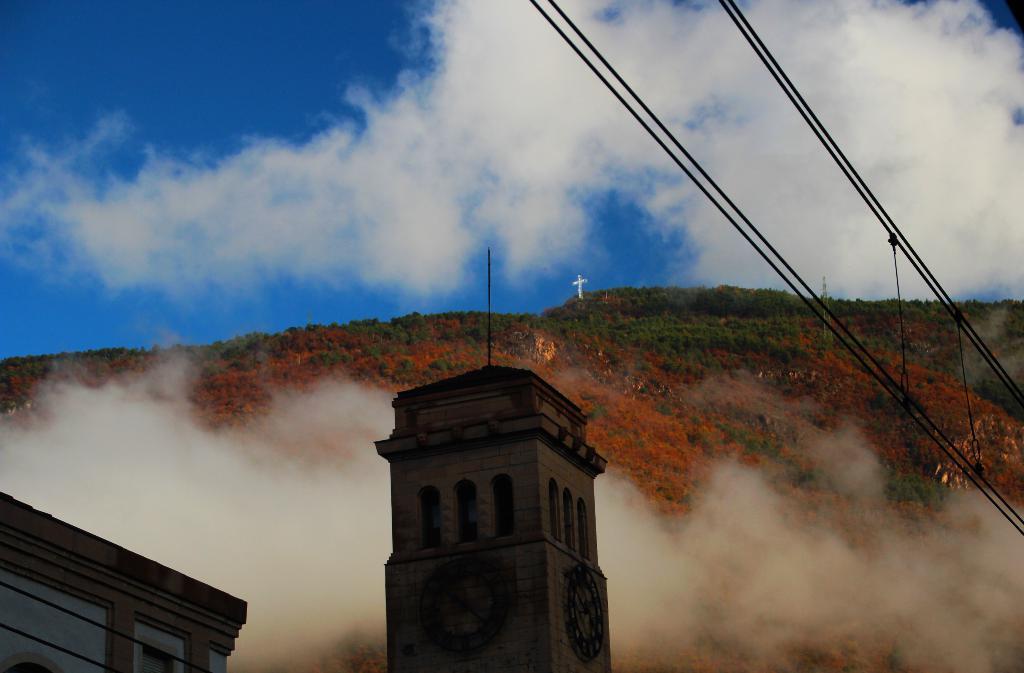Could you give a brief overview of what you see in this image? In this picture there is a building and there is a clock on the tower. At the back there is a mountain and there is a tower and there is a cross and there are trees on the mountain. At the top there is sky and there are clouds and wires. 